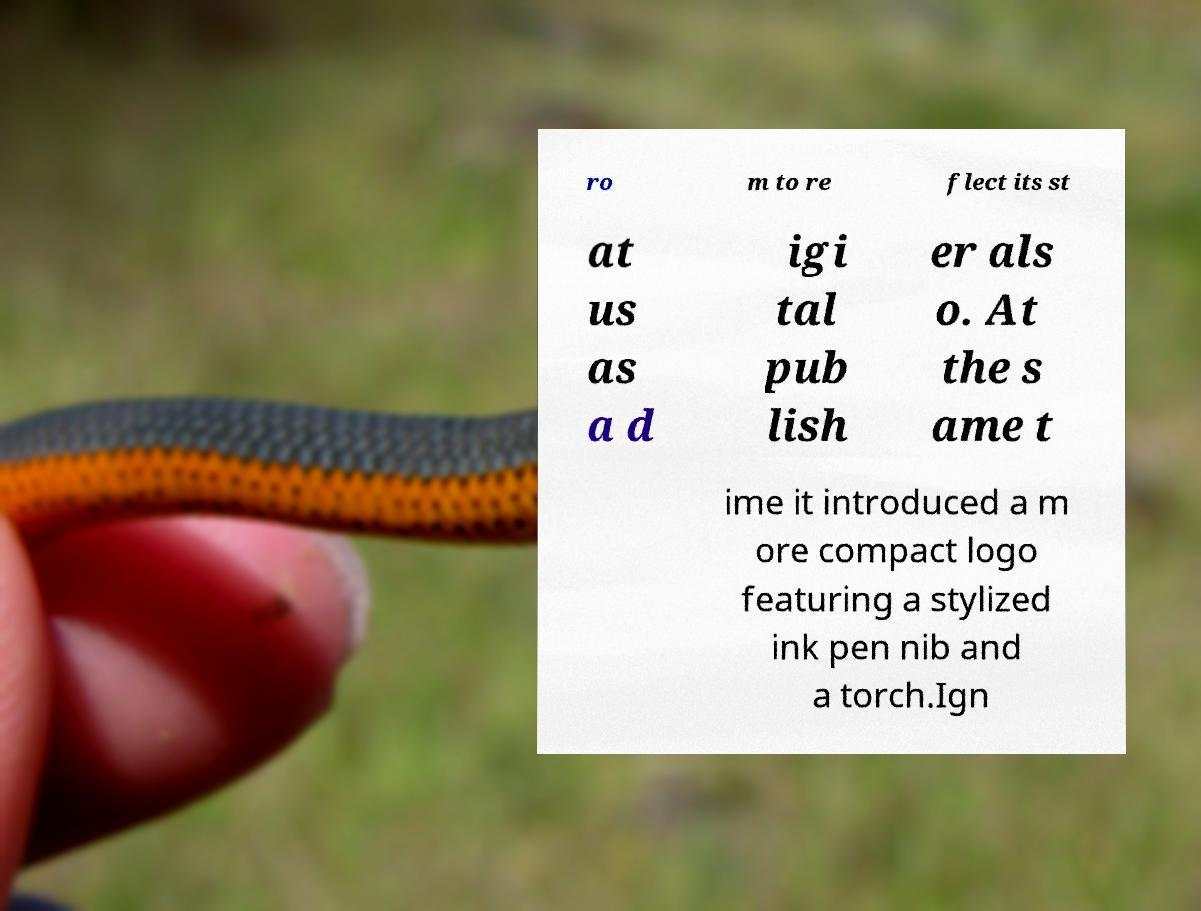Can you accurately transcribe the text from the provided image for me? ro m to re flect its st at us as a d igi tal pub lish er als o. At the s ame t ime it introduced a m ore compact logo featuring a stylized ink pen nib and a torch.Ign 